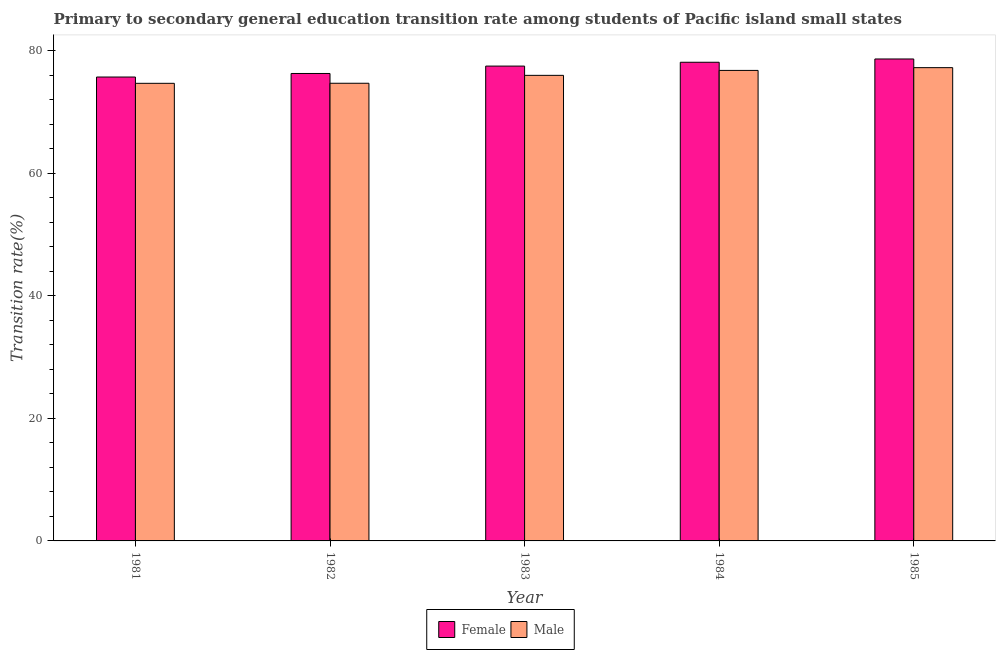How many bars are there on the 4th tick from the left?
Provide a succinct answer. 2. How many bars are there on the 5th tick from the right?
Ensure brevity in your answer.  2. What is the label of the 3rd group of bars from the left?
Make the answer very short. 1983. What is the transition rate among male students in 1984?
Provide a short and direct response. 76.78. Across all years, what is the maximum transition rate among female students?
Make the answer very short. 78.64. Across all years, what is the minimum transition rate among male students?
Provide a succinct answer. 74.67. In which year was the transition rate among female students maximum?
Give a very brief answer. 1985. What is the total transition rate among male students in the graph?
Offer a very short reply. 379.32. What is the difference between the transition rate among male students in 1984 and that in 1985?
Keep it short and to the point. -0.45. What is the difference between the transition rate among female students in 1984 and the transition rate among male students in 1982?
Your answer should be compact. 1.83. What is the average transition rate among female students per year?
Keep it short and to the point. 77.24. In how many years, is the transition rate among female students greater than 32 %?
Your response must be concise. 5. What is the ratio of the transition rate among female students in 1982 to that in 1984?
Ensure brevity in your answer.  0.98. Is the transition rate among male students in 1983 less than that in 1984?
Provide a succinct answer. Yes. Is the difference between the transition rate among male students in 1981 and 1983 greater than the difference between the transition rate among female students in 1981 and 1983?
Your answer should be compact. No. What is the difference between the highest and the second highest transition rate among female students?
Your response must be concise. 0.54. What is the difference between the highest and the lowest transition rate among male students?
Your response must be concise. 2.56. In how many years, is the transition rate among male students greater than the average transition rate among male students taken over all years?
Your answer should be compact. 3. Is the sum of the transition rate among female students in 1982 and 1985 greater than the maximum transition rate among male students across all years?
Keep it short and to the point. Yes. What does the 1st bar from the left in 1984 represents?
Keep it short and to the point. Female. Are the values on the major ticks of Y-axis written in scientific E-notation?
Your response must be concise. No. Does the graph contain grids?
Make the answer very short. No. What is the title of the graph?
Offer a very short reply. Primary to secondary general education transition rate among students of Pacific island small states. What is the label or title of the Y-axis?
Offer a very short reply. Transition rate(%). What is the Transition rate(%) in Female in 1981?
Provide a succinct answer. 75.7. What is the Transition rate(%) of Male in 1981?
Give a very brief answer. 74.67. What is the Transition rate(%) of Female in 1982?
Make the answer very short. 76.28. What is the Transition rate(%) in Male in 1982?
Ensure brevity in your answer.  74.68. What is the Transition rate(%) in Female in 1983?
Offer a terse response. 77.48. What is the Transition rate(%) in Male in 1983?
Keep it short and to the point. 75.97. What is the Transition rate(%) of Female in 1984?
Make the answer very short. 78.11. What is the Transition rate(%) of Male in 1984?
Make the answer very short. 76.78. What is the Transition rate(%) of Female in 1985?
Provide a succinct answer. 78.64. What is the Transition rate(%) in Male in 1985?
Your answer should be very brief. 77.23. Across all years, what is the maximum Transition rate(%) in Female?
Offer a very short reply. 78.64. Across all years, what is the maximum Transition rate(%) in Male?
Ensure brevity in your answer.  77.23. Across all years, what is the minimum Transition rate(%) of Female?
Offer a very short reply. 75.7. Across all years, what is the minimum Transition rate(%) in Male?
Provide a succinct answer. 74.67. What is the total Transition rate(%) of Female in the graph?
Your response must be concise. 386.2. What is the total Transition rate(%) of Male in the graph?
Give a very brief answer. 379.32. What is the difference between the Transition rate(%) of Female in 1981 and that in 1982?
Ensure brevity in your answer.  -0.58. What is the difference between the Transition rate(%) of Male in 1981 and that in 1982?
Your answer should be very brief. -0.01. What is the difference between the Transition rate(%) of Female in 1981 and that in 1983?
Offer a very short reply. -1.78. What is the difference between the Transition rate(%) in Male in 1981 and that in 1983?
Keep it short and to the point. -1.3. What is the difference between the Transition rate(%) in Female in 1981 and that in 1984?
Provide a short and direct response. -2.41. What is the difference between the Transition rate(%) in Male in 1981 and that in 1984?
Your answer should be very brief. -2.11. What is the difference between the Transition rate(%) of Female in 1981 and that in 1985?
Provide a short and direct response. -2.95. What is the difference between the Transition rate(%) of Male in 1981 and that in 1985?
Provide a succinct answer. -2.56. What is the difference between the Transition rate(%) in Female in 1982 and that in 1983?
Offer a very short reply. -1.21. What is the difference between the Transition rate(%) of Male in 1982 and that in 1983?
Provide a short and direct response. -1.29. What is the difference between the Transition rate(%) in Female in 1982 and that in 1984?
Offer a very short reply. -1.83. What is the difference between the Transition rate(%) in Male in 1982 and that in 1984?
Give a very brief answer. -2.1. What is the difference between the Transition rate(%) in Female in 1982 and that in 1985?
Provide a succinct answer. -2.37. What is the difference between the Transition rate(%) in Male in 1982 and that in 1985?
Your answer should be compact. -2.55. What is the difference between the Transition rate(%) in Female in 1983 and that in 1984?
Your answer should be compact. -0.63. What is the difference between the Transition rate(%) of Male in 1983 and that in 1984?
Offer a very short reply. -0.81. What is the difference between the Transition rate(%) in Female in 1983 and that in 1985?
Offer a terse response. -1.16. What is the difference between the Transition rate(%) in Male in 1983 and that in 1985?
Your response must be concise. -1.26. What is the difference between the Transition rate(%) of Female in 1984 and that in 1985?
Provide a succinct answer. -0.54. What is the difference between the Transition rate(%) in Male in 1984 and that in 1985?
Give a very brief answer. -0.45. What is the difference between the Transition rate(%) in Female in 1981 and the Transition rate(%) in Male in 1982?
Your answer should be compact. 1.02. What is the difference between the Transition rate(%) of Female in 1981 and the Transition rate(%) of Male in 1983?
Your answer should be very brief. -0.27. What is the difference between the Transition rate(%) of Female in 1981 and the Transition rate(%) of Male in 1984?
Ensure brevity in your answer.  -1.08. What is the difference between the Transition rate(%) of Female in 1981 and the Transition rate(%) of Male in 1985?
Your answer should be compact. -1.53. What is the difference between the Transition rate(%) of Female in 1982 and the Transition rate(%) of Male in 1983?
Your response must be concise. 0.3. What is the difference between the Transition rate(%) of Female in 1982 and the Transition rate(%) of Male in 1984?
Your response must be concise. -0.5. What is the difference between the Transition rate(%) in Female in 1982 and the Transition rate(%) in Male in 1985?
Provide a short and direct response. -0.95. What is the difference between the Transition rate(%) of Female in 1983 and the Transition rate(%) of Male in 1984?
Make the answer very short. 0.71. What is the difference between the Transition rate(%) in Female in 1983 and the Transition rate(%) in Male in 1985?
Keep it short and to the point. 0.25. What is the difference between the Transition rate(%) of Female in 1984 and the Transition rate(%) of Male in 1985?
Make the answer very short. 0.88. What is the average Transition rate(%) of Female per year?
Keep it short and to the point. 77.24. What is the average Transition rate(%) of Male per year?
Offer a terse response. 75.86. In the year 1981, what is the difference between the Transition rate(%) of Female and Transition rate(%) of Male?
Ensure brevity in your answer.  1.03. In the year 1982, what is the difference between the Transition rate(%) in Female and Transition rate(%) in Male?
Make the answer very short. 1.59. In the year 1983, what is the difference between the Transition rate(%) of Female and Transition rate(%) of Male?
Make the answer very short. 1.51. In the year 1984, what is the difference between the Transition rate(%) in Female and Transition rate(%) in Male?
Your answer should be compact. 1.33. In the year 1985, what is the difference between the Transition rate(%) of Female and Transition rate(%) of Male?
Make the answer very short. 1.42. What is the ratio of the Transition rate(%) in Female in 1981 to that in 1982?
Provide a succinct answer. 0.99. What is the ratio of the Transition rate(%) in Female in 1981 to that in 1983?
Provide a succinct answer. 0.98. What is the ratio of the Transition rate(%) of Male in 1981 to that in 1983?
Keep it short and to the point. 0.98. What is the ratio of the Transition rate(%) of Female in 1981 to that in 1984?
Your response must be concise. 0.97. What is the ratio of the Transition rate(%) in Male in 1981 to that in 1984?
Ensure brevity in your answer.  0.97. What is the ratio of the Transition rate(%) of Female in 1981 to that in 1985?
Your answer should be compact. 0.96. What is the ratio of the Transition rate(%) of Male in 1981 to that in 1985?
Offer a very short reply. 0.97. What is the ratio of the Transition rate(%) in Female in 1982 to that in 1983?
Give a very brief answer. 0.98. What is the ratio of the Transition rate(%) in Female in 1982 to that in 1984?
Provide a succinct answer. 0.98. What is the ratio of the Transition rate(%) of Male in 1982 to that in 1984?
Keep it short and to the point. 0.97. What is the ratio of the Transition rate(%) of Female in 1982 to that in 1985?
Ensure brevity in your answer.  0.97. What is the ratio of the Transition rate(%) in Male in 1982 to that in 1985?
Provide a succinct answer. 0.97. What is the ratio of the Transition rate(%) in Female in 1983 to that in 1984?
Keep it short and to the point. 0.99. What is the ratio of the Transition rate(%) of Male in 1983 to that in 1984?
Your response must be concise. 0.99. What is the ratio of the Transition rate(%) of Female in 1983 to that in 1985?
Give a very brief answer. 0.99. What is the ratio of the Transition rate(%) of Male in 1983 to that in 1985?
Ensure brevity in your answer.  0.98. What is the ratio of the Transition rate(%) in Male in 1984 to that in 1985?
Your answer should be compact. 0.99. What is the difference between the highest and the second highest Transition rate(%) in Female?
Your answer should be very brief. 0.54. What is the difference between the highest and the second highest Transition rate(%) in Male?
Provide a short and direct response. 0.45. What is the difference between the highest and the lowest Transition rate(%) in Female?
Your answer should be very brief. 2.95. What is the difference between the highest and the lowest Transition rate(%) of Male?
Offer a very short reply. 2.56. 